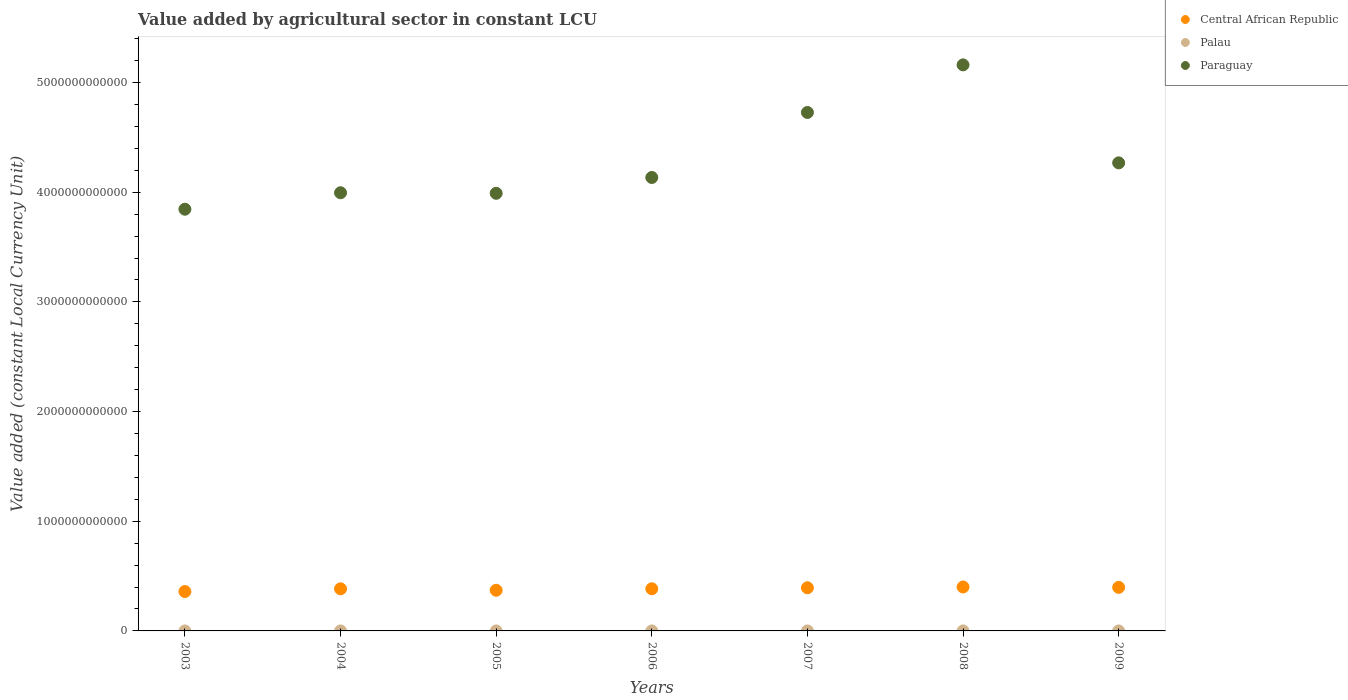How many different coloured dotlines are there?
Provide a succinct answer. 3. Is the number of dotlines equal to the number of legend labels?
Keep it short and to the point. Yes. What is the value added by agricultural sector in Palau in 2004?
Give a very brief answer. 7.16e+06. Across all years, what is the maximum value added by agricultural sector in Central African Republic?
Your response must be concise. 4.01e+11. Across all years, what is the minimum value added by agricultural sector in Palau?
Give a very brief answer. 7.00e+06. In which year was the value added by agricultural sector in Paraguay maximum?
Your response must be concise. 2008. What is the total value added by agricultural sector in Paraguay in the graph?
Keep it short and to the point. 3.01e+13. What is the difference between the value added by agricultural sector in Central African Republic in 2007 and that in 2009?
Make the answer very short. -3.73e+09. What is the difference between the value added by agricultural sector in Palau in 2007 and the value added by agricultural sector in Paraguay in 2009?
Keep it short and to the point. -4.27e+12. What is the average value added by agricultural sector in Paraguay per year?
Give a very brief answer. 4.30e+12. In the year 2009, what is the difference between the value added by agricultural sector in Central African Republic and value added by agricultural sector in Palau?
Provide a succinct answer. 3.97e+11. In how many years, is the value added by agricultural sector in Paraguay greater than 5200000000000 LCU?
Provide a succinct answer. 0. What is the ratio of the value added by agricultural sector in Central African Republic in 2004 to that in 2005?
Your response must be concise. 1.03. Is the value added by agricultural sector in Palau in 2004 less than that in 2009?
Provide a succinct answer. No. Is the difference between the value added by agricultural sector in Central African Republic in 2005 and 2009 greater than the difference between the value added by agricultural sector in Palau in 2005 and 2009?
Offer a very short reply. No. What is the difference between the highest and the second highest value added by agricultural sector in Paraguay?
Make the answer very short. 4.34e+11. What is the difference between the highest and the lowest value added by agricultural sector in Palau?
Provide a succinct answer. 1.28e+06. In how many years, is the value added by agricultural sector in Central African Republic greater than the average value added by agricultural sector in Central African Republic taken over all years?
Offer a terse response. 4. Is it the case that in every year, the sum of the value added by agricultural sector in Palau and value added by agricultural sector in Central African Republic  is greater than the value added by agricultural sector in Paraguay?
Ensure brevity in your answer.  No. Does the value added by agricultural sector in Central African Republic monotonically increase over the years?
Ensure brevity in your answer.  No. Is the value added by agricultural sector in Paraguay strictly greater than the value added by agricultural sector in Palau over the years?
Your answer should be very brief. Yes. What is the difference between two consecutive major ticks on the Y-axis?
Make the answer very short. 1.00e+12. Are the values on the major ticks of Y-axis written in scientific E-notation?
Keep it short and to the point. No. Does the graph contain any zero values?
Offer a terse response. No. Does the graph contain grids?
Provide a succinct answer. No. How many legend labels are there?
Keep it short and to the point. 3. What is the title of the graph?
Offer a very short reply. Value added by agricultural sector in constant LCU. Does "Slovak Republic" appear as one of the legend labels in the graph?
Offer a very short reply. No. What is the label or title of the X-axis?
Offer a very short reply. Years. What is the label or title of the Y-axis?
Ensure brevity in your answer.  Value added (constant Local Currency Unit). What is the Value added (constant Local Currency Unit) of Central African Republic in 2003?
Your answer should be very brief. 3.59e+11. What is the Value added (constant Local Currency Unit) in Palau in 2003?
Ensure brevity in your answer.  7.02e+06. What is the Value added (constant Local Currency Unit) of Paraguay in 2003?
Provide a succinct answer. 3.85e+12. What is the Value added (constant Local Currency Unit) in Central African Republic in 2004?
Ensure brevity in your answer.  3.84e+11. What is the Value added (constant Local Currency Unit) in Palau in 2004?
Make the answer very short. 7.16e+06. What is the Value added (constant Local Currency Unit) of Paraguay in 2004?
Provide a succinct answer. 4.00e+12. What is the Value added (constant Local Currency Unit) in Central African Republic in 2005?
Keep it short and to the point. 3.71e+11. What is the Value added (constant Local Currency Unit) of Palau in 2005?
Provide a short and direct response. 7.64e+06. What is the Value added (constant Local Currency Unit) in Paraguay in 2005?
Ensure brevity in your answer.  3.99e+12. What is the Value added (constant Local Currency Unit) of Central African Republic in 2006?
Offer a terse response. 3.84e+11. What is the Value added (constant Local Currency Unit) of Palau in 2006?
Offer a very short reply. 8.27e+06. What is the Value added (constant Local Currency Unit) in Paraguay in 2006?
Give a very brief answer. 4.13e+12. What is the Value added (constant Local Currency Unit) of Central African Republic in 2007?
Your response must be concise. 3.93e+11. What is the Value added (constant Local Currency Unit) in Palau in 2007?
Give a very brief answer. 7.64e+06. What is the Value added (constant Local Currency Unit) in Paraguay in 2007?
Your answer should be compact. 4.73e+12. What is the Value added (constant Local Currency Unit) in Central African Republic in 2008?
Your answer should be very brief. 4.01e+11. What is the Value added (constant Local Currency Unit) of Palau in 2008?
Offer a very short reply. 7.84e+06. What is the Value added (constant Local Currency Unit) in Paraguay in 2008?
Offer a terse response. 5.16e+12. What is the Value added (constant Local Currency Unit) in Central African Republic in 2009?
Provide a short and direct response. 3.97e+11. What is the Value added (constant Local Currency Unit) of Palau in 2009?
Keep it short and to the point. 7.00e+06. What is the Value added (constant Local Currency Unit) of Paraguay in 2009?
Offer a terse response. 4.27e+12. Across all years, what is the maximum Value added (constant Local Currency Unit) in Central African Republic?
Keep it short and to the point. 4.01e+11. Across all years, what is the maximum Value added (constant Local Currency Unit) of Palau?
Your response must be concise. 8.27e+06. Across all years, what is the maximum Value added (constant Local Currency Unit) of Paraguay?
Your answer should be compact. 5.16e+12. Across all years, what is the minimum Value added (constant Local Currency Unit) of Central African Republic?
Your response must be concise. 3.59e+11. Across all years, what is the minimum Value added (constant Local Currency Unit) of Palau?
Make the answer very short. 7.00e+06. Across all years, what is the minimum Value added (constant Local Currency Unit) in Paraguay?
Keep it short and to the point. 3.85e+12. What is the total Value added (constant Local Currency Unit) in Central African Republic in the graph?
Provide a short and direct response. 2.69e+12. What is the total Value added (constant Local Currency Unit) of Palau in the graph?
Your response must be concise. 5.26e+07. What is the total Value added (constant Local Currency Unit) of Paraguay in the graph?
Provide a short and direct response. 3.01e+13. What is the difference between the Value added (constant Local Currency Unit) in Central African Republic in 2003 and that in 2004?
Your response must be concise. -2.45e+1. What is the difference between the Value added (constant Local Currency Unit) of Palau in 2003 and that in 2004?
Ensure brevity in your answer.  -1.42e+05. What is the difference between the Value added (constant Local Currency Unit) of Paraguay in 2003 and that in 2004?
Your answer should be compact. -1.50e+11. What is the difference between the Value added (constant Local Currency Unit) in Central African Republic in 2003 and that in 2005?
Give a very brief answer. -1.15e+1. What is the difference between the Value added (constant Local Currency Unit) in Palau in 2003 and that in 2005?
Provide a succinct answer. -6.21e+05. What is the difference between the Value added (constant Local Currency Unit) of Paraguay in 2003 and that in 2005?
Your response must be concise. -1.45e+11. What is the difference between the Value added (constant Local Currency Unit) of Central African Republic in 2003 and that in 2006?
Give a very brief answer. -2.48e+1. What is the difference between the Value added (constant Local Currency Unit) of Palau in 2003 and that in 2006?
Ensure brevity in your answer.  -1.26e+06. What is the difference between the Value added (constant Local Currency Unit) of Paraguay in 2003 and that in 2006?
Provide a short and direct response. -2.89e+11. What is the difference between the Value added (constant Local Currency Unit) in Central African Republic in 2003 and that in 2007?
Your answer should be very brief. -3.40e+1. What is the difference between the Value added (constant Local Currency Unit) in Palau in 2003 and that in 2007?
Provide a short and direct response. -6.20e+05. What is the difference between the Value added (constant Local Currency Unit) of Paraguay in 2003 and that in 2007?
Make the answer very short. -8.82e+11. What is the difference between the Value added (constant Local Currency Unit) of Central African Republic in 2003 and that in 2008?
Provide a short and direct response. -4.13e+1. What is the difference between the Value added (constant Local Currency Unit) in Palau in 2003 and that in 2008?
Your answer should be compact. -8.23e+05. What is the difference between the Value added (constant Local Currency Unit) of Paraguay in 2003 and that in 2008?
Give a very brief answer. -1.32e+12. What is the difference between the Value added (constant Local Currency Unit) in Central African Republic in 2003 and that in 2009?
Your answer should be compact. -3.77e+1. What is the difference between the Value added (constant Local Currency Unit) of Palau in 2003 and that in 2009?
Keep it short and to the point. 2.12e+04. What is the difference between the Value added (constant Local Currency Unit) in Paraguay in 2003 and that in 2009?
Provide a short and direct response. -4.23e+11. What is the difference between the Value added (constant Local Currency Unit) in Central African Republic in 2004 and that in 2005?
Your response must be concise. 1.30e+1. What is the difference between the Value added (constant Local Currency Unit) of Palau in 2004 and that in 2005?
Make the answer very short. -4.79e+05. What is the difference between the Value added (constant Local Currency Unit) of Paraguay in 2004 and that in 2005?
Ensure brevity in your answer.  4.87e+09. What is the difference between the Value added (constant Local Currency Unit) in Central African Republic in 2004 and that in 2006?
Give a very brief answer. -3.58e+08. What is the difference between the Value added (constant Local Currency Unit) in Palau in 2004 and that in 2006?
Ensure brevity in your answer.  -1.11e+06. What is the difference between the Value added (constant Local Currency Unit) in Paraguay in 2004 and that in 2006?
Your response must be concise. -1.39e+11. What is the difference between the Value added (constant Local Currency Unit) of Central African Republic in 2004 and that in 2007?
Give a very brief answer. -9.53e+09. What is the difference between the Value added (constant Local Currency Unit) in Palau in 2004 and that in 2007?
Give a very brief answer. -4.78e+05. What is the difference between the Value added (constant Local Currency Unit) of Paraguay in 2004 and that in 2007?
Offer a very short reply. -7.32e+11. What is the difference between the Value added (constant Local Currency Unit) of Central African Republic in 2004 and that in 2008?
Provide a short and direct response. -1.68e+1. What is the difference between the Value added (constant Local Currency Unit) of Palau in 2004 and that in 2008?
Give a very brief answer. -6.81e+05. What is the difference between the Value added (constant Local Currency Unit) of Paraguay in 2004 and that in 2008?
Your response must be concise. -1.17e+12. What is the difference between the Value added (constant Local Currency Unit) in Central African Republic in 2004 and that in 2009?
Make the answer very short. -1.33e+1. What is the difference between the Value added (constant Local Currency Unit) of Palau in 2004 and that in 2009?
Your answer should be very brief. 1.63e+05. What is the difference between the Value added (constant Local Currency Unit) in Paraguay in 2004 and that in 2009?
Your answer should be compact. -2.73e+11. What is the difference between the Value added (constant Local Currency Unit) in Central African Republic in 2005 and that in 2006?
Your response must be concise. -1.33e+1. What is the difference between the Value added (constant Local Currency Unit) of Palau in 2005 and that in 2006?
Your answer should be very brief. -6.36e+05. What is the difference between the Value added (constant Local Currency Unit) of Paraguay in 2005 and that in 2006?
Provide a short and direct response. -1.44e+11. What is the difference between the Value added (constant Local Currency Unit) of Central African Republic in 2005 and that in 2007?
Make the answer very short. -2.25e+1. What is the difference between the Value added (constant Local Currency Unit) of Palau in 2005 and that in 2007?
Make the answer very short. 778.28. What is the difference between the Value added (constant Local Currency Unit) in Paraguay in 2005 and that in 2007?
Give a very brief answer. -7.37e+11. What is the difference between the Value added (constant Local Currency Unit) in Central African Republic in 2005 and that in 2008?
Your answer should be very brief. -2.98e+1. What is the difference between the Value added (constant Local Currency Unit) of Palau in 2005 and that in 2008?
Keep it short and to the point. -2.02e+05. What is the difference between the Value added (constant Local Currency Unit) in Paraguay in 2005 and that in 2008?
Provide a short and direct response. -1.17e+12. What is the difference between the Value added (constant Local Currency Unit) of Central African Republic in 2005 and that in 2009?
Make the answer very short. -2.62e+1. What is the difference between the Value added (constant Local Currency Unit) in Palau in 2005 and that in 2009?
Your answer should be compact. 6.42e+05. What is the difference between the Value added (constant Local Currency Unit) in Paraguay in 2005 and that in 2009?
Your response must be concise. -2.78e+11. What is the difference between the Value added (constant Local Currency Unit) of Central African Republic in 2006 and that in 2007?
Your response must be concise. -9.17e+09. What is the difference between the Value added (constant Local Currency Unit) in Palau in 2006 and that in 2007?
Provide a short and direct response. 6.37e+05. What is the difference between the Value added (constant Local Currency Unit) of Paraguay in 2006 and that in 2007?
Your response must be concise. -5.93e+11. What is the difference between the Value added (constant Local Currency Unit) of Central African Republic in 2006 and that in 2008?
Your response must be concise. -1.64e+1. What is the difference between the Value added (constant Local Currency Unit) in Palau in 2006 and that in 2008?
Provide a succinct answer. 4.34e+05. What is the difference between the Value added (constant Local Currency Unit) of Paraguay in 2006 and that in 2008?
Your response must be concise. -1.03e+12. What is the difference between the Value added (constant Local Currency Unit) of Central African Republic in 2006 and that in 2009?
Make the answer very short. -1.29e+1. What is the difference between the Value added (constant Local Currency Unit) in Palau in 2006 and that in 2009?
Offer a very short reply. 1.28e+06. What is the difference between the Value added (constant Local Currency Unit) in Paraguay in 2006 and that in 2009?
Offer a terse response. -1.33e+11. What is the difference between the Value added (constant Local Currency Unit) in Central African Republic in 2007 and that in 2008?
Give a very brief answer. -7.28e+09. What is the difference between the Value added (constant Local Currency Unit) of Palau in 2007 and that in 2008?
Offer a very short reply. -2.03e+05. What is the difference between the Value added (constant Local Currency Unit) in Paraguay in 2007 and that in 2008?
Give a very brief answer. -4.34e+11. What is the difference between the Value added (constant Local Currency Unit) of Central African Republic in 2007 and that in 2009?
Your answer should be very brief. -3.73e+09. What is the difference between the Value added (constant Local Currency Unit) of Palau in 2007 and that in 2009?
Your answer should be very brief. 6.41e+05. What is the difference between the Value added (constant Local Currency Unit) in Paraguay in 2007 and that in 2009?
Make the answer very short. 4.60e+11. What is the difference between the Value added (constant Local Currency Unit) of Central African Republic in 2008 and that in 2009?
Ensure brevity in your answer.  3.55e+09. What is the difference between the Value added (constant Local Currency Unit) of Palau in 2008 and that in 2009?
Provide a succinct answer. 8.44e+05. What is the difference between the Value added (constant Local Currency Unit) in Paraguay in 2008 and that in 2009?
Your response must be concise. 8.93e+11. What is the difference between the Value added (constant Local Currency Unit) of Central African Republic in 2003 and the Value added (constant Local Currency Unit) of Palau in 2004?
Offer a very short reply. 3.59e+11. What is the difference between the Value added (constant Local Currency Unit) of Central African Republic in 2003 and the Value added (constant Local Currency Unit) of Paraguay in 2004?
Your response must be concise. -3.64e+12. What is the difference between the Value added (constant Local Currency Unit) in Palau in 2003 and the Value added (constant Local Currency Unit) in Paraguay in 2004?
Give a very brief answer. -4.00e+12. What is the difference between the Value added (constant Local Currency Unit) of Central African Republic in 2003 and the Value added (constant Local Currency Unit) of Palau in 2005?
Ensure brevity in your answer.  3.59e+11. What is the difference between the Value added (constant Local Currency Unit) in Central African Republic in 2003 and the Value added (constant Local Currency Unit) in Paraguay in 2005?
Give a very brief answer. -3.63e+12. What is the difference between the Value added (constant Local Currency Unit) of Palau in 2003 and the Value added (constant Local Currency Unit) of Paraguay in 2005?
Keep it short and to the point. -3.99e+12. What is the difference between the Value added (constant Local Currency Unit) in Central African Republic in 2003 and the Value added (constant Local Currency Unit) in Palau in 2006?
Your answer should be very brief. 3.59e+11. What is the difference between the Value added (constant Local Currency Unit) of Central African Republic in 2003 and the Value added (constant Local Currency Unit) of Paraguay in 2006?
Offer a very short reply. -3.78e+12. What is the difference between the Value added (constant Local Currency Unit) in Palau in 2003 and the Value added (constant Local Currency Unit) in Paraguay in 2006?
Offer a very short reply. -4.13e+12. What is the difference between the Value added (constant Local Currency Unit) in Central African Republic in 2003 and the Value added (constant Local Currency Unit) in Palau in 2007?
Offer a very short reply. 3.59e+11. What is the difference between the Value added (constant Local Currency Unit) in Central African Republic in 2003 and the Value added (constant Local Currency Unit) in Paraguay in 2007?
Your response must be concise. -4.37e+12. What is the difference between the Value added (constant Local Currency Unit) of Palau in 2003 and the Value added (constant Local Currency Unit) of Paraguay in 2007?
Offer a terse response. -4.73e+12. What is the difference between the Value added (constant Local Currency Unit) of Central African Republic in 2003 and the Value added (constant Local Currency Unit) of Palau in 2008?
Your response must be concise. 3.59e+11. What is the difference between the Value added (constant Local Currency Unit) of Central African Republic in 2003 and the Value added (constant Local Currency Unit) of Paraguay in 2008?
Give a very brief answer. -4.80e+12. What is the difference between the Value added (constant Local Currency Unit) in Palau in 2003 and the Value added (constant Local Currency Unit) in Paraguay in 2008?
Your response must be concise. -5.16e+12. What is the difference between the Value added (constant Local Currency Unit) of Central African Republic in 2003 and the Value added (constant Local Currency Unit) of Palau in 2009?
Offer a terse response. 3.59e+11. What is the difference between the Value added (constant Local Currency Unit) in Central African Republic in 2003 and the Value added (constant Local Currency Unit) in Paraguay in 2009?
Offer a terse response. -3.91e+12. What is the difference between the Value added (constant Local Currency Unit) of Palau in 2003 and the Value added (constant Local Currency Unit) of Paraguay in 2009?
Your response must be concise. -4.27e+12. What is the difference between the Value added (constant Local Currency Unit) of Central African Republic in 2004 and the Value added (constant Local Currency Unit) of Palau in 2005?
Your response must be concise. 3.84e+11. What is the difference between the Value added (constant Local Currency Unit) of Central African Republic in 2004 and the Value added (constant Local Currency Unit) of Paraguay in 2005?
Keep it short and to the point. -3.61e+12. What is the difference between the Value added (constant Local Currency Unit) in Palau in 2004 and the Value added (constant Local Currency Unit) in Paraguay in 2005?
Your response must be concise. -3.99e+12. What is the difference between the Value added (constant Local Currency Unit) of Central African Republic in 2004 and the Value added (constant Local Currency Unit) of Palau in 2006?
Offer a terse response. 3.84e+11. What is the difference between the Value added (constant Local Currency Unit) of Central African Republic in 2004 and the Value added (constant Local Currency Unit) of Paraguay in 2006?
Your response must be concise. -3.75e+12. What is the difference between the Value added (constant Local Currency Unit) of Palau in 2004 and the Value added (constant Local Currency Unit) of Paraguay in 2006?
Offer a very short reply. -4.13e+12. What is the difference between the Value added (constant Local Currency Unit) in Central African Republic in 2004 and the Value added (constant Local Currency Unit) in Palau in 2007?
Offer a very short reply. 3.84e+11. What is the difference between the Value added (constant Local Currency Unit) in Central African Republic in 2004 and the Value added (constant Local Currency Unit) in Paraguay in 2007?
Your answer should be compact. -4.34e+12. What is the difference between the Value added (constant Local Currency Unit) in Palau in 2004 and the Value added (constant Local Currency Unit) in Paraguay in 2007?
Offer a terse response. -4.73e+12. What is the difference between the Value added (constant Local Currency Unit) in Central African Republic in 2004 and the Value added (constant Local Currency Unit) in Palau in 2008?
Your answer should be very brief. 3.84e+11. What is the difference between the Value added (constant Local Currency Unit) of Central African Republic in 2004 and the Value added (constant Local Currency Unit) of Paraguay in 2008?
Provide a short and direct response. -4.78e+12. What is the difference between the Value added (constant Local Currency Unit) of Palau in 2004 and the Value added (constant Local Currency Unit) of Paraguay in 2008?
Your answer should be compact. -5.16e+12. What is the difference between the Value added (constant Local Currency Unit) of Central African Republic in 2004 and the Value added (constant Local Currency Unit) of Palau in 2009?
Your answer should be compact. 3.84e+11. What is the difference between the Value added (constant Local Currency Unit) of Central African Republic in 2004 and the Value added (constant Local Currency Unit) of Paraguay in 2009?
Your response must be concise. -3.88e+12. What is the difference between the Value added (constant Local Currency Unit) of Palau in 2004 and the Value added (constant Local Currency Unit) of Paraguay in 2009?
Make the answer very short. -4.27e+12. What is the difference between the Value added (constant Local Currency Unit) in Central African Republic in 2005 and the Value added (constant Local Currency Unit) in Palau in 2006?
Your response must be concise. 3.71e+11. What is the difference between the Value added (constant Local Currency Unit) in Central African Republic in 2005 and the Value added (constant Local Currency Unit) in Paraguay in 2006?
Give a very brief answer. -3.76e+12. What is the difference between the Value added (constant Local Currency Unit) in Palau in 2005 and the Value added (constant Local Currency Unit) in Paraguay in 2006?
Provide a succinct answer. -4.13e+12. What is the difference between the Value added (constant Local Currency Unit) in Central African Republic in 2005 and the Value added (constant Local Currency Unit) in Palau in 2007?
Offer a very short reply. 3.71e+11. What is the difference between the Value added (constant Local Currency Unit) in Central African Republic in 2005 and the Value added (constant Local Currency Unit) in Paraguay in 2007?
Keep it short and to the point. -4.36e+12. What is the difference between the Value added (constant Local Currency Unit) in Palau in 2005 and the Value added (constant Local Currency Unit) in Paraguay in 2007?
Ensure brevity in your answer.  -4.73e+12. What is the difference between the Value added (constant Local Currency Unit) of Central African Republic in 2005 and the Value added (constant Local Currency Unit) of Palau in 2008?
Keep it short and to the point. 3.71e+11. What is the difference between the Value added (constant Local Currency Unit) in Central African Republic in 2005 and the Value added (constant Local Currency Unit) in Paraguay in 2008?
Keep it short and to the point. -4.79e+12. What is the difference between the Value added (constant Local Currency Unit) in Palau in 2005 and the Value added (constant Local Currency Unit) in Paraguay in 2008?
Keep it short and to the point. -5.16e+12. What is the difference between the Value added (constant Local Currency Unit) of Central African Republic in 2005 and the Value added (constant Local Currency Unit) of Palau in 2009?
Offer a very short reply. 3.71e+11. What is the difference between the Value added (constant Local Currency Unit) in Central African Republic in 2005 and the Value added (constant Local Currency Unit) in Paraguay in 2009?
Your answer should be compact. -3.90e+12. What is the difference between the Value added (constant Local Currency Unit) in Palau in 2005 and the Value added (constant Local Currency Unit) in Paraguay in 2009?
Provide a short and direct response. -4.27e+12. What is the difference between the Value added (constant Local Currency Unit) in Central African Republic in 2006 and the Value added (constant Local Currency Unit) in Palau in 2007?
Ensure brevity in your answer.  3.84e+11. What is the difference between the Value added (constant Local Currency Unit) of Central African Republic in 2006 and the Value added (constant Local Currency Unit) of Paraguay in 2007?
Your response must be concise. -4.34e+12. What is the difference between the Value added (constant Local Currency Unit) of Palau in 2006 and the Value added (constant Local Currency Unit) of Paraguay in 2007?
Offer a terse response. -4.73e+12. What is the difference between the Value added (constant Local Currency Unit) of Central African Republic in 2006 and the Value added (constant Local Currency Unit) of Palau in 2008?
Offer a terse response. 3.84e+11. What is the difference between the Value added (constant Local Currency Unit) of Central African Republic in 2006 and the Value added (constant Local Currency Unit) of Paraguay in 2008?
Your answer should be compact. -4.78e+12. What is the difference between the Value added (constant Local Currency Unit) of Palau in 2006 and the Value added (constant Local Currency Unit) of Paraguay in 2008?
Provide a succinct answer. -5.16e+12. What is the difference between the Value added (constant Local Currency Unit) of Central African Republic in 2006 and the Value added (constant Local Currency Unit) of Palau in 2009?
Give a very brief answer. 3.84e+11. What is the difference between the Value added (constant Local Currency Unit) in Central African Republic in 2006 and the Value added (constant Local Currency Unit) in Paraguay in 2009?
Ensure brevity in your answer.  -3.88e+12. What is the difference between the Value added (constant Local Currency Unit) of Palau in 2006 and the Value added (constant Local Currency Unit) of Paraguay in 2009?
Keep it short and to the point. -4.27e+12. What is the difference between the Value added (constant Local Currency Unit) in Central African Republic in 2007 and the Value added (constant Local Currency Unit) in Palau in 2008?
Offer a terse response. 3.93e+11. What is the difference between the Value added (constant Local Currency Unit) in Central African Republic in 2007 and the Value added (constant Local Currency Unit) in Paraguay in 2008?
Provide a short and direct response. -4.77e+12. What is the difference between the Value added (constant Local Currency Unit) in Palau in 2007 and the Value added (constant Local Currency Unit) in Paraguay in 2008?
Provide a short and direct response. -5.16e+12. What is the difference between the Value added (constant Local Currency Unit) of Central African Republic in 2007 and the Value added (constant Local Currency Unit) of Palau in 2009?
Provide a succinct answer. 3.93e+11. What is the difference between the Value added (constant Local Currency Unit) in Central African Republic in 2007 and the Value added (constant Local Currency Unit) in Paraguay in 2009?
Make the answer very short. -3.87e+12. What is the difference between the Value added (constant Local Currency Unit) in Palau in 2007 and the Value added (constant Local Currency Unit) in Paraguay in 2009?
Ensure brevity in your answer.  -4.27e+12. What is the difference between the Value added (constant Local Currency Unit) of Central African Republic in 2008 and the Value added (constant Local Currency Unit) of Palau in 2009?
Your answer should be compact. 4.01e+11. What is the difference between the Value added (constant Local Currency Unit) in Central African Republic in 2008 and the Value added (constant Local Currency Unit) in Paraguay in 2009?
Provide a succinct answer. -3.87e+12. What is the difference between the Value added (constant Local Currency Unit) in Palau in 2008 and the Value added (constant Local Currency Unit) in Paraguay in 2009?
Your answer should be very brief. -4.27e+12. What is the average Value added (constant Local Currency Unit) in Central African Republic per year?
Offer a very short reply. 3.84e+11. What is the average Value added (constant Local Currency Unit) in Palau per year?
Offer a terse response. 7.51e+06. What is the average Value added (constant Local Currency Unit) in Paraguay per year?
Give a very brief answer. 4.30e+12. In the year 2003, what is the difference between the Value added (constant Local Currency Unit) in Central African Republic and Value added (constant Local Currency Unit) in Palau?
Your answer should be compact. 3.59e+11. In the year 2003, what is the difference between the Value added (constant Local Currency Unit) in Central African Republic and Value added (constant Local Currency Unit) in Paraguay?
Provide a succinct answer. -3.49e+12. In the year 2003, what is the difference between the Value added (constant Local Currency Unit) in Palau and Value added (constant Local Currency Unit) in Paraguay?
Give a very brief answer. -3.85e+12. In the year 2004, what is the difference between the Value added (constant Local Currency Unit) in Central African Republic and Value added (constant Local Currency Unit) in Palau?
Ensure brevity in your answer.  3.84e+11. In the year 2004, what is the difference between the Value added (constant Local Currency Unit) of Central African Republic and Value added (constant Local Currency Unit) of Paraguay?
Offer a terse response. -3.61e+12. In the year 2004, what is the difference between the Value added (constant Local Currency Unit) of Palau and Value added (constant Local Currency Unit) of Paraguay?
Provide a short and direct response. -4.00e+12. In the year 2005, what is the difference between the Value added (constant Local Currency Unit) in Central African Republic and Value added (constant Local Currency Unit) in Palau?
Provide a succinct answer. 3.71e+11. In the year 2005, what is the difference between the Value added (constant Local Currency Unit) in Central African Republic and Value added (constant Local Currency Unit) in Paraguay?
Provide a succinct answer. -3.62e+12. In the year 2005, what is the difference between the Value added (constant Local Currency Unit) in Palau and Value added (constant Local Currency Unit) in Paraguay?
Give a very brief answer. -3.99e+12. In the year 2006, what is the difference between the Value added (constant Local Currency Unit) of Central African Republic and Value added (constant Local Currency Unit) of Palau?
Give a very brief answer. 3.84e+11. In the year 2006, what is the difference between the Value added (constant Local Currency Unit) in Central African Republic and Value added (constant Local Currency Unit) in Paraguay?
Provide a succinct answer. -3.75e+12. In the year 2006, what is the difference between the Value added (constant Local Currency Unit) in Palau and Value added (constant Local Currency Unit) in Paraguay?
Your answer should be very brief. -4.13e+12. In the year 2007, what is the difference between the Value added (constant Local Currency Unit) in Central African Republic and Value added (constant Local Currency Unit) in Palau?
Give a very brief answer. 3.93e+11. In the year 2007, what is the difference between the Value added (constant Local Currency Unit) in Central African Republic and Value added (constant Local Currency Unit) in Paraguay?
Your answer should be compact. -4.33e+12. In the year 2007, what is the difference between the Value added (constant Local Currency Unit) in Palau and Value added (constant Local Currency Unit) in Paraguay?
Ensure brevity in your answer.  -4.73e+12. In the year 2008, what is the difference between the Value added (constant Local Currency Unit) of Central African Republic and Value added (constant Local Currency Unit) of Palau?
Provide a succinct answer. 4.01e+11. In the year 2008, what is the difference between the Value added (constant Local Currency Unit) of Central African Republic and Value added (constant Local Currency Unit) of Paraguay?
Provide a succinct answer. -4.76e+12. In the year 2008, what is the difference between the Value added (constant Local Currency Unit) of Palau and Value added (constant Local Currency Unit) of Paraguay?
Keep it short and to the point. -5.16e+12. In the year 2009, what is the difference between the Value added (constant Local Currency Unit) of Central African Republic and Value added (constant Local Currency Unit) of Palau?
Your response must be concise. 3.97e+11. In the year 2009, what is the difference between the Value added (constant Local Currency Unit) in Central African Republic and Value added (constant Local Currency Unit) in Paraguay?
Your answer should be compact. -3.87e+12. In the year 2009, what is the difference between the Value added (constant Local Currency Unit) of Palau and Value added (constant Local Currency Unit) of Paraguay?
Offer a terse response. -4.27e+12. What is the ratio of the Value added (constant Local Currency Unit) of Central African Republic in 2003 to that in 2004?
Your response must be concise. 0.94. What is the ratio of the Value added (constant Local Currency Unit) of Palau in 2003 to that in 2004?
Provide a succinct answer. 0.98. What is the ratio of the Value added (constant Local Currency Unit) in Paraguay in 2003 to that in 2004?
Keep it short and to the point. 0.96. What is the ratio of the Value added (constant Local Currency Unit) of Central African Republic in 2003 to that in 2005?
Keep it short and to the point. 0.97. What is the ratio of the Value added (constant Local Currency Unit) in Palau in 2003 to that in 2005?
Offer a terse response. 0.92. What is the ratio of the Value added (constant Local Currency Unit) in Paraguay in 2003 to that in 2005?
Provide a short and direct response. 0.96. What is the ratio of the Value added (constant Local Currency Unit) in Central African Republic in 2003 to that in 2006?
Offer a very short reply. 0.94. What is the ratio of the Value added (constant Local Currency Unit) in Palau in 2003 to that in 2006?
Keep it short and to the point. 0.85. What is the ratio of the Value added (constant Local Currency Unit) in Paraguay in 2003 to that in 2006?
Provide a succinct answer. 0.93. What is the ratio of the Value added (constant Local Currency Unit) in Central African Republic in 2003 to that in 2007?
Your answer should be very brief. 0.91. What is the ratio of the Value added (constant Local Currency Unit) of Palau in 2003 to that in 2007?
Your answer should be compact. 0.92. What is the ratio of the Value added (constant Local Currency Unit) in Paraguay in 2003 to that in 2007?
Provide a succinct answer. 0.81. What is the ratio of the Value added (constant Local Currency Unit) in Central African Republic in 2003 to that in 2008?
Your answer should be very brief. 0.9. What is the ratio of the Value added (constant Local Currency Unit) in Palau in 2003 to that in 2008?
Provide a short and direct response. 0.9. What is the ratio of the Value added (constant Local Currency Unit) of Paraguay in 2003 to that in 2008?
Your answer should be compact. 0.74. What is the ratio of the Value added (constant Local Currency Unit) of Central African Republic in 2003 to that in 2009?
Provide a succinct answer. 0.9. What is the ratio of the Value added (constant Local Currency Unit) in Palau in 2003 to that in 2009?
Keep it short and to the point. 1. What is the ratio of the Value added (constant Local Currency Unit) in Paraguay in 2003 to that in 2009?
Offer a very short reply. 0.9. What is the ratio of the Value added (constant Local Currency Unit) in Central African Republic in 2004 to that in 2005?
Keep it short and to the point. 1.03. What is the ratio of the Value added (constant Local Currency Unit) in Palau in 2004 to that in 2005?
Offer a terse response. 0.94. What is the ratio of the Value added (constant Local Currency Unit) of Paraguay in 2004 to that in 2005?
Your response must be concise. 1. What is the ratio of the Value added (constant Local Currency Unit) of Central African Republic in 2004 to that in 2006?
Your answer should be compact. 1. What is the ratio of the Value added (constant Local Currency Unit) in Palau in 2004 to that in 2006?
Ensure brevity in your answer.  0.87. What is the ratio of the Value added (constant Local Currency Unit) of Paraguay in 2004 to that in 2006?
Your answer should be very brief. 0.97. What is the ratio of the Value added (constant Local Currency Unit) in Central African Republic in 2004 to that in 2007?
Make the answer very short. 0.98. What is the ratio of the Value added (constant Local Currency Unit) in Paraguay in 2004 to that in 2007?
Make the answer very short. 0.85. What is the ratio of the Value added (constant Local Currency Unit) of Central African Republic in 2004 to that in 2008?
Your response must be concise. 0.96. What is the ratio of the Value added (constant Local Currency Unit) in Palau in 2004 to that in 2008?
Give a very brief answer. 0.91. What is the ratio of the Value added (constant Local Currency Unit) in Paraguay in 2004 to that in 2008?
Give a very brief answer. 0.77. What is the ratio of the Value added (constant Local Currency Unit) in Central African Republic in 2004 to that in 2009?
Make the answer very short. 0.97. What is the ratio of the Value added (constant Local Currency Unit) in Palau in 2004 to that in 2009?
Your answer should be compact. 1.02. What is the ratio of the Value added (constant Local Currency Unit) in Paraguay in 2004 to that in 2009?
Your response must be concise. 0.94. What is the ratio of the Value added (constant Local Currency Unit) of Central African Republic in 2005 to that in 2006?
Ensure brevity in your answer.  0.97. What is the ratio of the Value added (constant Local Currency Unit) in Palau in 2005 to that in 2006?
Your answer should be very brief. 0.92. What is the ratio of the Value added (constant Local Currency Unit) in Paraguay in 2005 to that in 2006?
Make the answer very short. 0.97. What is the ratio of the Value added (constant Local Currency Unit) in Central African Republic in 2005 to that in 2007?
Provide a short and direct response. 0.94. What is the ratio of the Value added (constant Local Currency Unit) in Palau in 2005 to that in 2007?
Keep it short and to the point. 1. What is the ratio of the Value added (constant Local Currency Unit) in Paraguay in 2005 to that in 2007?
Offer a very short reply. 0.84. What is the ratio of the Value added (constant Local Currency Unit) of Central African Republic in 2005 to that in 2008?
Offer a very short reply. 0.93. What is the ratio of the Value added (constant Local Currency Unit) in Palau in 2005 to that in 2008?
Offer a very short reply. 0.97. What is the ratio of the Value added (constant Local Currency Unit) of Paraguay in 2005 to that in 2008?
Your answer should be very brief. 0.77. What is the ratio of the Value added (constant Local Currency Unit) of Central African Republic in 2005 to that in 2009?
Provide a short and direct response. 0.93. What is the ratio of the Value added (constant Local Currency Unit) of Palau in 2005 to that in 2009?
Offer a terse response. 1.09. What is the ratio of the Value added (constant Local Currency Unit) of Paraguay in 2005 to that in 2009?
Your answer should be very brief. 0.94. What is the ratio of the Value added (constant Local Currency Unit) in Central African Republic in 2006 to that in 2007?
Keep it short and to the point. 0.98. What is the ratio of the Value added (constant Local Currency Unit) in Palau in 2006 to that in 2007?
Provide a succinct answer. 1.08. What is the ratio of the Value added (constant Local Currency Unit) in Paraguay in 2006 to that in 2007?
Your response must be concise. 0.87. What is the ratio of the Value added (constant Local Currency Unit) of Central African Republic in 2006 to that in 2008?
Make the answer very short. 0.96. What is the ratio of the Value added (constant Local Currency Unit) in Palau in 2006 to that in 2008?
Offer a very short reply. 1.06. What is the ratio of the Value added (constant Local Currency Unit) of Paraguay in 2006 to that in 2008?
Make the answer very short. 0.8. What is the ratio of the Value added (constant Local Currency Unit) in Central African Republic in 2006 to that in 2009?
Ensure brevity in your answer.  0.97. What is the ratio of the Value added (constant Local Currency Unit) in Palau in 2006 to that in 2009?
Ensure brevity in your answer.  1.18. What is the ratio of the Value added (constant Local Currency Unit) of Paraguay in 2006 to that in 2009?
Give a very brief answer. 0.97. What is the ratio of the Value added (constant Local Currency Unit) of Central African Republic in 2007 to that in 2008?
Ensure brevity in your answer.  0.98. What is the ratio of the Value added (constant Local Currency Unit) in Palau in 2007 to that in 2008?
Your response must be concise. 0.97. What is the ratio of the Value added (constant Local Currency Unit) of Paraguay in 2007 to that in 2008?
Give a very brief answer. 0.92. What is the ratio of the Value added (constant Local Currency Unit) in Central African Republic in 2007 to that in 2009?
Make the answer very short. 0.99. What is the ratio of the Value added (constant Local Currency Unit) in Palau in 2007 to that in 2009?
Offer a very short reply. 1.09. What is the ratio of the Value added (constant Local Currency Unit) in Paraguay in 2007 to that in 2009?
Offer a terse response. 1.11. What is the ratio of the Value added (constant Local Currency Unit) of Central African Republic in 2008 to that in 2009?
Keep it short and to the point. 1.01. What is the ratio of the Value added (constant Local Currency Unit) in Palau in 2008 to that in 2009?
Offer a very short reply. 1.12. What is the ratio of the Value added (constant Local Currency Unit) in Paraguay in 2008 to that in 2009?
Your answer should be compact. 1.21. What is the difference between the highest and the second highest Value added (constant Local Currency Unit) of Central African Republic?
Provide a short and direct response. 3.55e+09. What is the difference between the highest and the second highest Value added (constant Local Currency Unit) in Palau?
Give a very brief answer. 4.34e+05. What is the difference between the highest and the second highest Value added (constant Local Currency Unit) in Paraguay?
Provide a short and direct response. 4.34e+11. What is the difference between the highest and the lowest Value added (constant Local Currency Unit) of Central African Republic?
Offer a very short reply. 4.13e+1. What is the difference between the highest and the lowest Value added (constant Local Currency Unit) of Palau?
Your answer should be very brief. 1.28e+06. What is the difference between the highest and the lowest Value added (constant Local Currency Unit) in Paraguay?
Offer a terse response. 1.32e+12. 